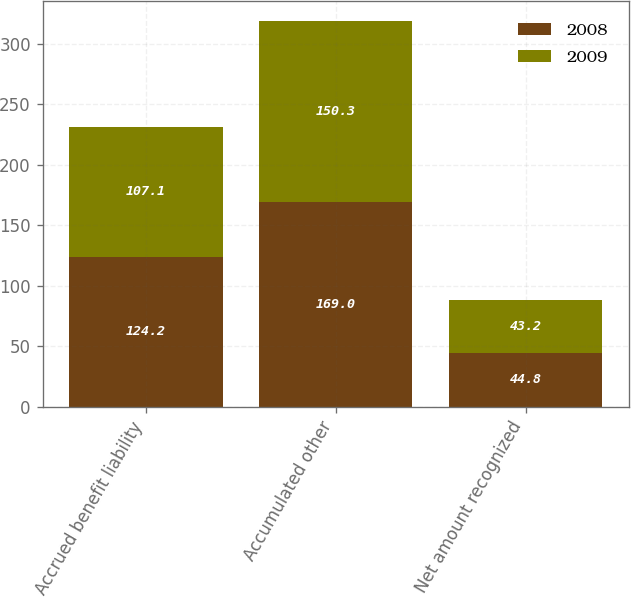<chart> <loc_0><loc_0><loc_500><loc_500><stacked_bar_chart><ecel><fcel>Accrued benefit liability<fcel>Accumulated other<fcel>Net amount recognized<nl><fcel>2008<fcel>124.2<fcel>169<fcel>44.8<nl><fcel>2009<fcel>107.1<fcel>150.3<fcel>43.2<nl></chart> 